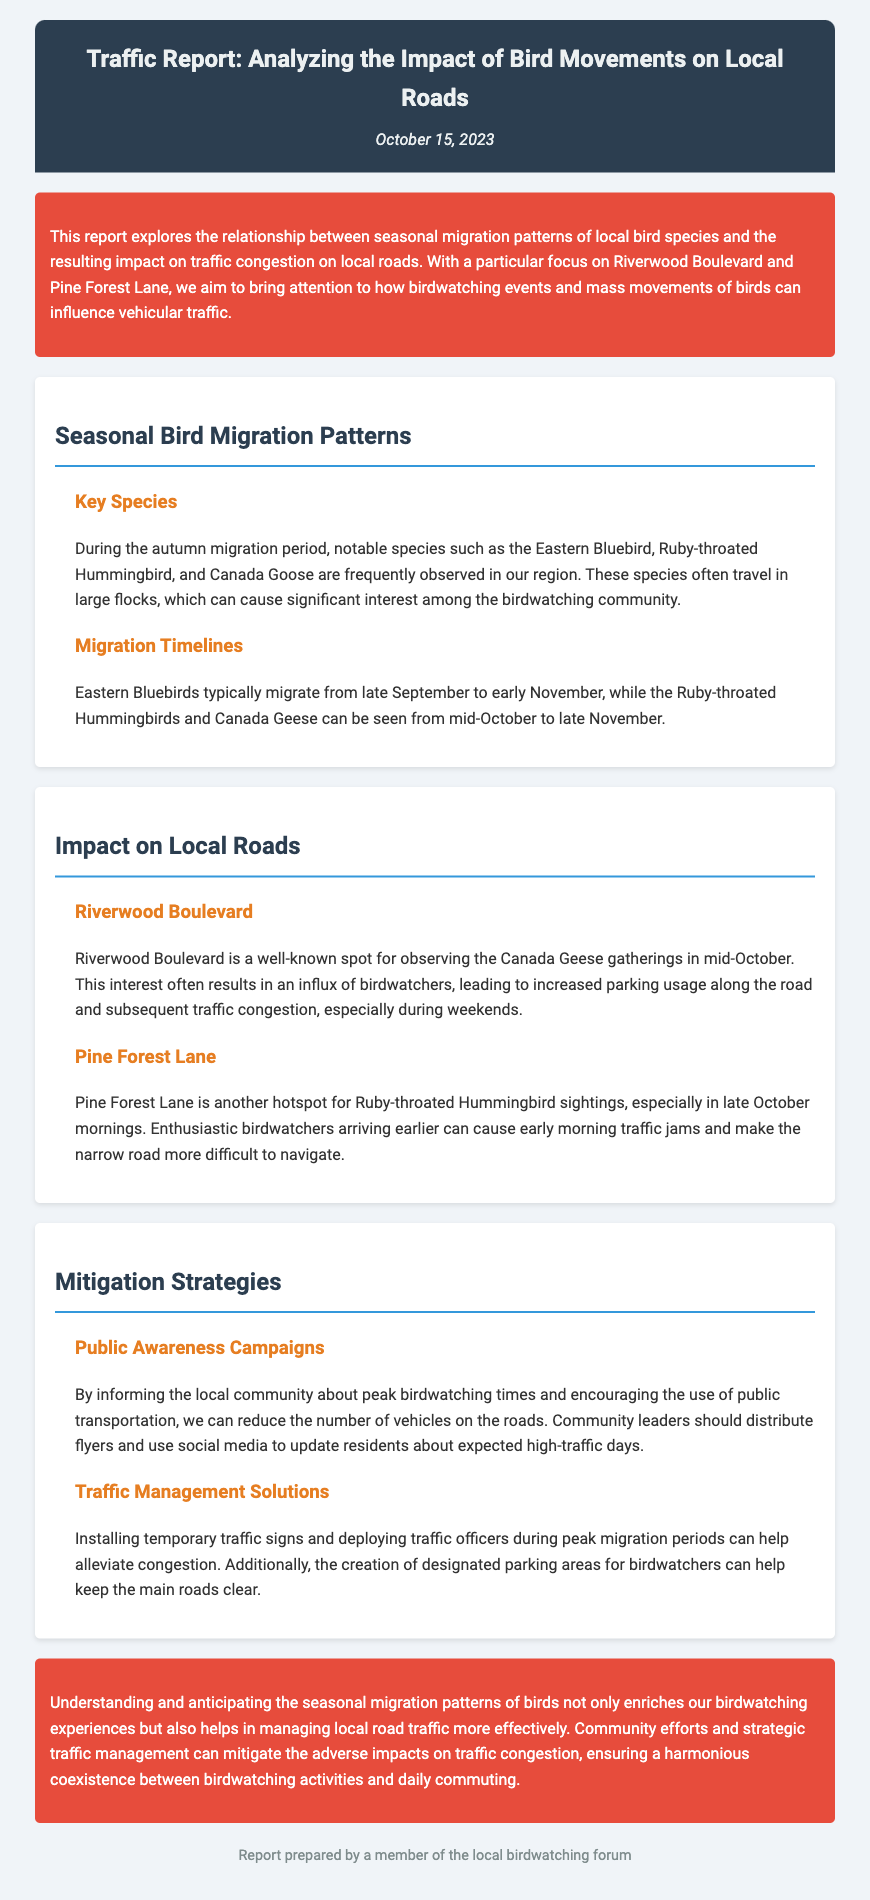What is the title of the report? The title is presented at the beginning of the document, highlighting the main focus of the report.
Answer: Traffic Report: Analyzing the Impact of Bird Movements on Local Roads During which months do Eastern Bluebirds typically migrate? The migration period for Eastern Bluebirds is specified in the migration timelines section of the document.
Answer: Late September to early November Which road experiences congestion due to Canada Geese gatherings? The section discussing Riverwood Boulevard identifies it as a hotspot for observing Canada Geese.
Answer: Riverwood Boulevard What type of awareness campaigns are mentioned as a mitigation strategy? The document discusses public awareness campaigns aimed at informing the local community about birdwatching times.
Answer: Public Awareness Campaigns What is a proposed solution to manage traffic during peak migration periods? The mitigation strategies section includes suggestions such as installing temporary traffic signs.
Answer: Installing temporary traffic signs 